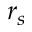<formula> <loc_0><loc_0><loc_500><loc_500>r _ { s }</formula> 